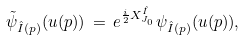<formula> <loc_0><loc_0><loc_500><loc_500>\tilde { \psi } _ { \hat { I } ( p ) } ( u ( p ) ) \, = \, e ^ { \frac { i } { 2 } X _ { J _ { 0 } } ^ { \hat { I } } } \psi _ { \hat { I } ( p ) } ( u ( p ) ) ,</formula> 